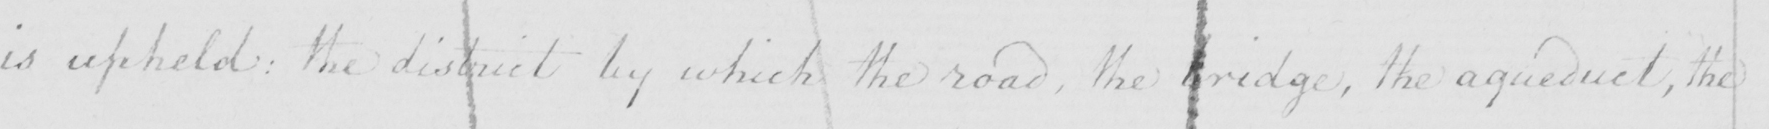Can you read and transcribe this handwriting? is upheld :  the district by which the road , the bridge , the aqueduct , the 